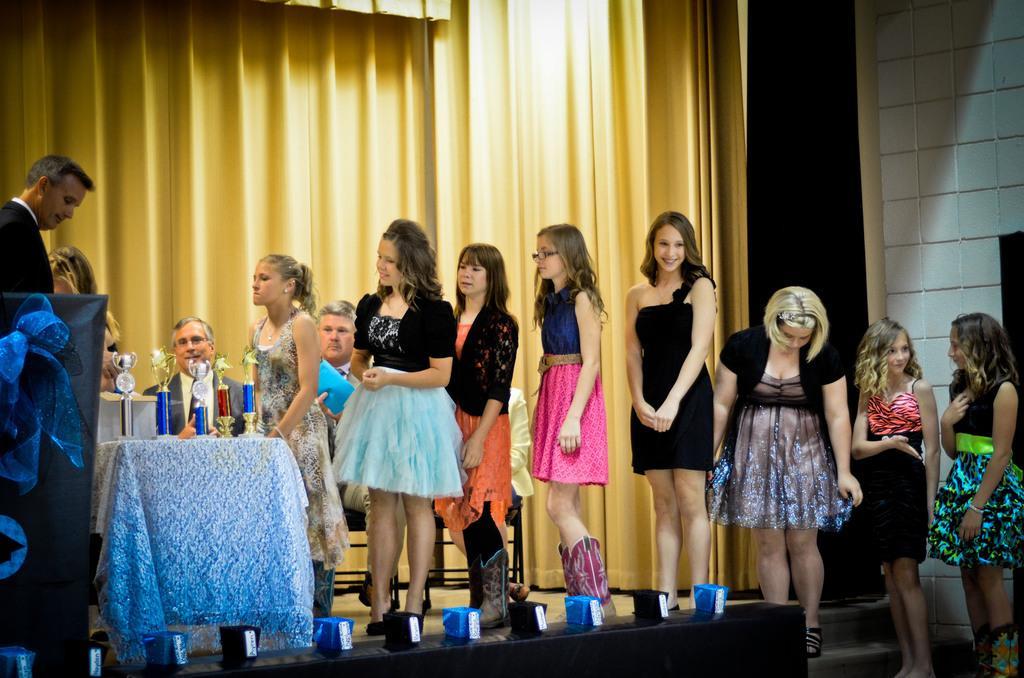Please provide a concise description of this image. In this image, I can see group of girls standing. This looks like a table, which is covered with a cloth. These are the trophies placed on the table. Here is the man standing. This looks like a board. I think this is a stage. I can see two men sitting on the chairs. These are the curtains hanging. This is the wall. 